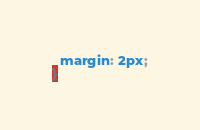<code> <loc_0><loc_0><loc_500><loc_500><_CSS_>  margin: 2px;
}</code> 